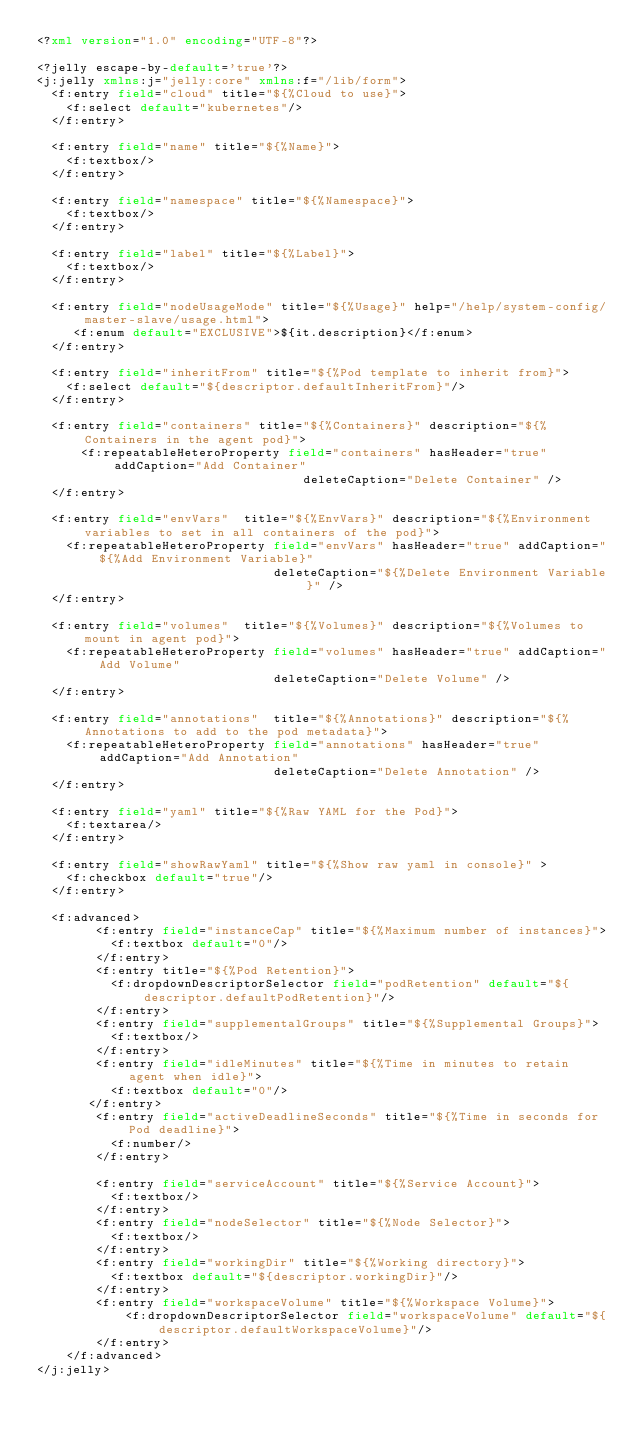Convert code to text. <code><loc_0><loc_0><loc_500><loc_500><_XML_><?xml version="1.0" encoding="UTF-8"?>

<?jelly escape-by-default='true'?>
<j:jelly xmlns:j="jelly:core" xmlns:f="/lib/form">
  <f:entry field="cloud" title="${%Cloud to use}">
    <f:select default="kubernetes"/>
  </f:entry>

  <f:entry field="name" title="${%Name}">
    <f:textbox/>
  </f:entry>

  <f:entry field="namespace" title="${%Namespace}">
    <f:textbox/>
  </f:entry>

  <f:entry field="label" title="${%Label}">
    <f:textbox/>
  </f:entry>

  <f:entry field="nodeUsageMode" title="${%Usage}" help="/help/system-config/master-slave/usage.html">
     <f:enum default="EXCLUSIVE">${it.description}</f:enum>
  </f:entry>

  <f:entry field="inheritFrom" title="${%Pod template to inherit from}">
    <f:select default="${descriptor.defaultInheritFrom}"/>
  </f:entry>

  <f:entry field="containers" title="${%Containers}" description="${%Containers in the agent pod}">
      <f:repeatableHeteroProperty field="containers" hasHeader="true" addCaption="Add Container"
                                    deleteCaption="Delete Container" />
  </f:entry>

  <f:entry field="envVars"  title="${%EnvVars}" description="${%Environment variables to set in all containers of the pod}">
    <f:repeatableHeteroProperty field="envVars" hasHeader="true" addCaption="${%Add Environment Variable}"
                                deleteCaption="${%Delete Environment Variable}" />
  </f:entry>

  <f:entry field="volumes"  title="${%Volumes}" description="${%Volumes to mount in agent pod}">
    <f:repeatableHeteroProperty field="volumes" hasHeader="true" addCaption="Add Volume"
                                deleteCaption="Delete Volume" />
  </f:entry>

  <f:entry field="annotations"  title="${%Annotations}" description="${%Annotations to add to the pod metadata}">
    <f:repeatableHeteroProperty field="annotations" hasHeader="true" addCaption="Add Annotation"
                                deleteCaption="Delete Annotation" />
  </f:entry>

  <f:entry field="yaml" title="${%Raw YAML for the Pod}">
    <f:textarea/>
  </f:entry>

  <f:entry field="showRawYaml" title="${%Show raw yaml in console}" >
    <f:checkbox default="true"/>
  </f:entry>

  <f:advanced>
        <f:entry field="instanceCap" title="${%Maximum number of instances}">
          <f:textbox default="0"/>
        </f:entry>
        <f:entry title="${%Pod Retention}">
          <f:dropdownDescriptorSelector field="podRetention" default="${descriptor.defaultPodRetention}"/>
        </f:entry>
        <f:entry field="supplementalGroups" title="${%Supplemental Groups}">
          <f:textbox/>
        </f:entry>
        <f:entry field="idleMinutes" title="${%Time in minutes to retain agent when idle}">
          <f:textbox default="0"/>
       </f:entry>
        <f:entry field="activeDeadlineSeconds" title="${%Time in seconds for Pod deadline}">
          <f:number/>
        </f:entry>

        <f:entry field="serviceAccount" title="${%Service Account}">
          <f:textbox/>
        </f:entry>
        <f:entry field="nodeSelector" title="${%Node Selector}">
          <f:textbox/>
        </f:entry>
        <f:entry field="workingDir" title="${%Working directory}">
          <f:textbox default="${descriptor.workingDir}"/>
        </f:entry>
        <f:entry field="workspaceVolume" title="${%Workspace Volume}">
            <f:dropdownDescriptorSelector field="workspaceVolume" default="${descriptor.defaultWorkspaceVolume}"/>
        </f:entry>
	</f:advanced>
</j:jelly>
</code> 